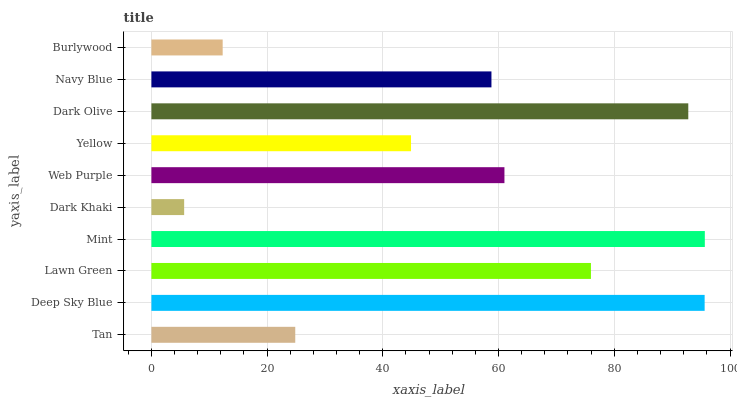Is Dark Khaki the minimum?
Answer yes or no. Yes. Is Mint the maximum?
Answer yes or no. Yes. Is Deep Sky Blue the minimum?
Answer yes or no. No. Is Deep Sky Blue the maximum?
Answer yes or no. No. Is Deep Sky Blue greater than Tan?
Answer yes or no. Yes. Is Tan less than Deep Sky Blue?
Answer yes or no. Yes. Is Tan greater than Deep Sky Blue?
Answer yes or no. No. Is Deep Sky Blue less than Tan?
Answer yes or no. No. Is Web Purple the high median?
Answer yes or no. Yes. Is Navy Blue the low median?
Answer yes or no. Yes. Is Navy Blue the high median?
Answer yes or no. No. Is Dark Khaki the low median?
Answer yes or no. No. 